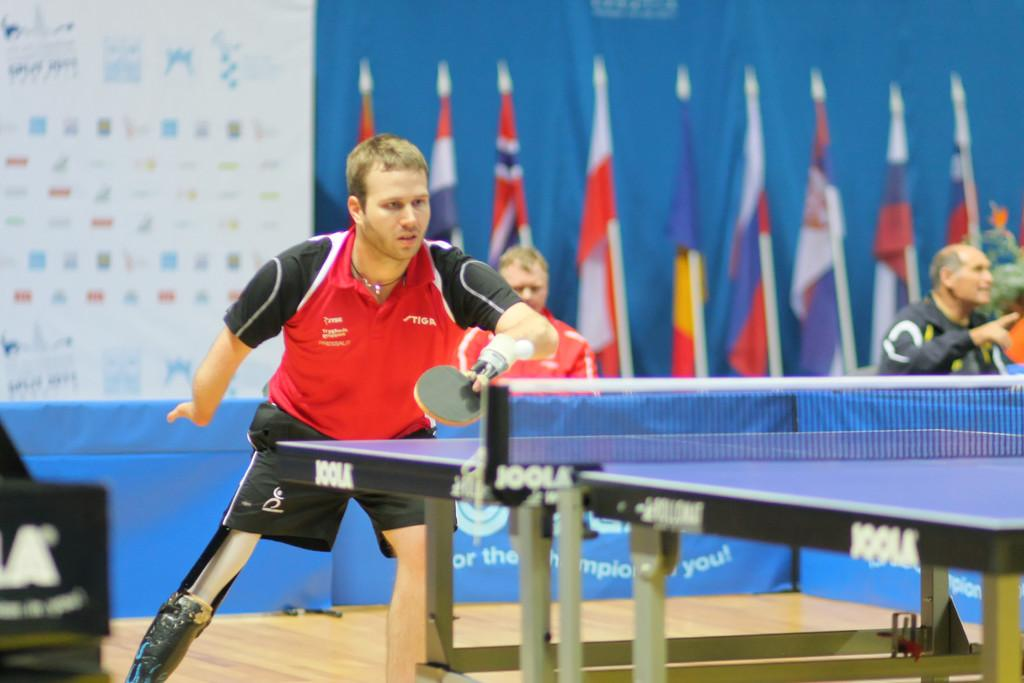What activity is the person in the image engaged in? The person is playing table tennis in the image. Which hand is the person using to play table tennis? The person is using their left hand to play. Can you describe the people in the background of the image? There are two persons sitting in the backdrop of the image. What additional elements can be seen in the image? There are flags visible in the image. What type of discovery was made using a wrench in the image? There is no discovery or wrench present in the image; it features a person playing table tennis. Is there a knife visible in the image? No, there is no knife present in the image. 